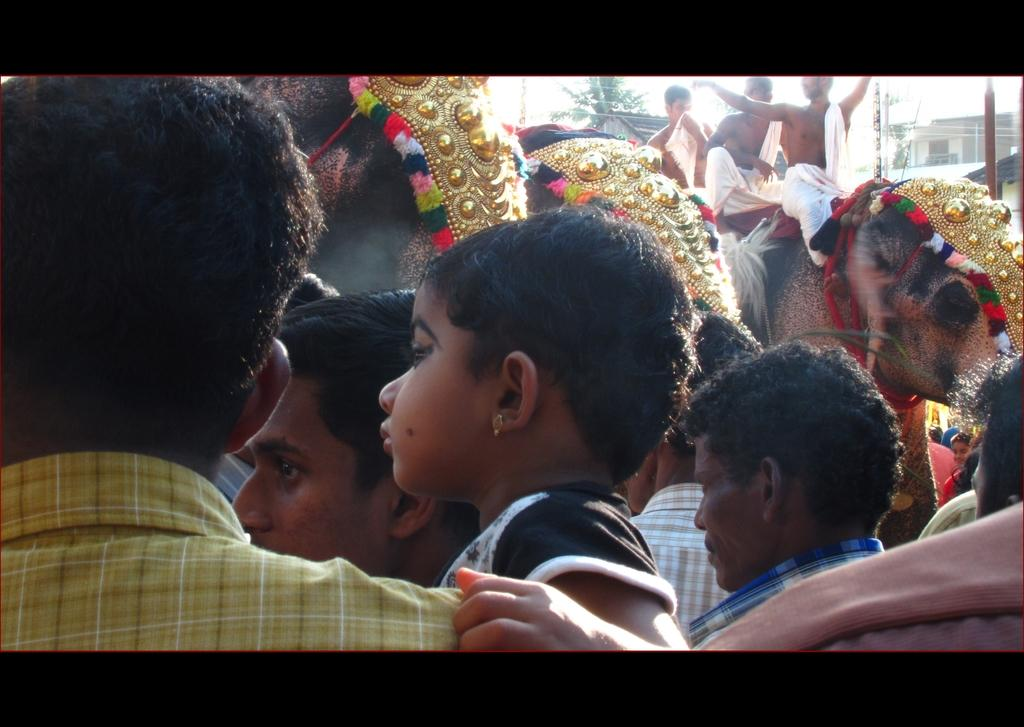What animals are present in the image? There are elephants in the image. Are there any people in the image? Yes, there are persons in the image. How many persons are sitting on an elephant? Three persons are sitting on an elephant. What can be seen in the background of the image? There are houses, poles, a tree, and the sky visible in the background of the image. Is there a lake in the image where the elephants are swimming? There is no lake present in the image, and the elephants are not swimming. 